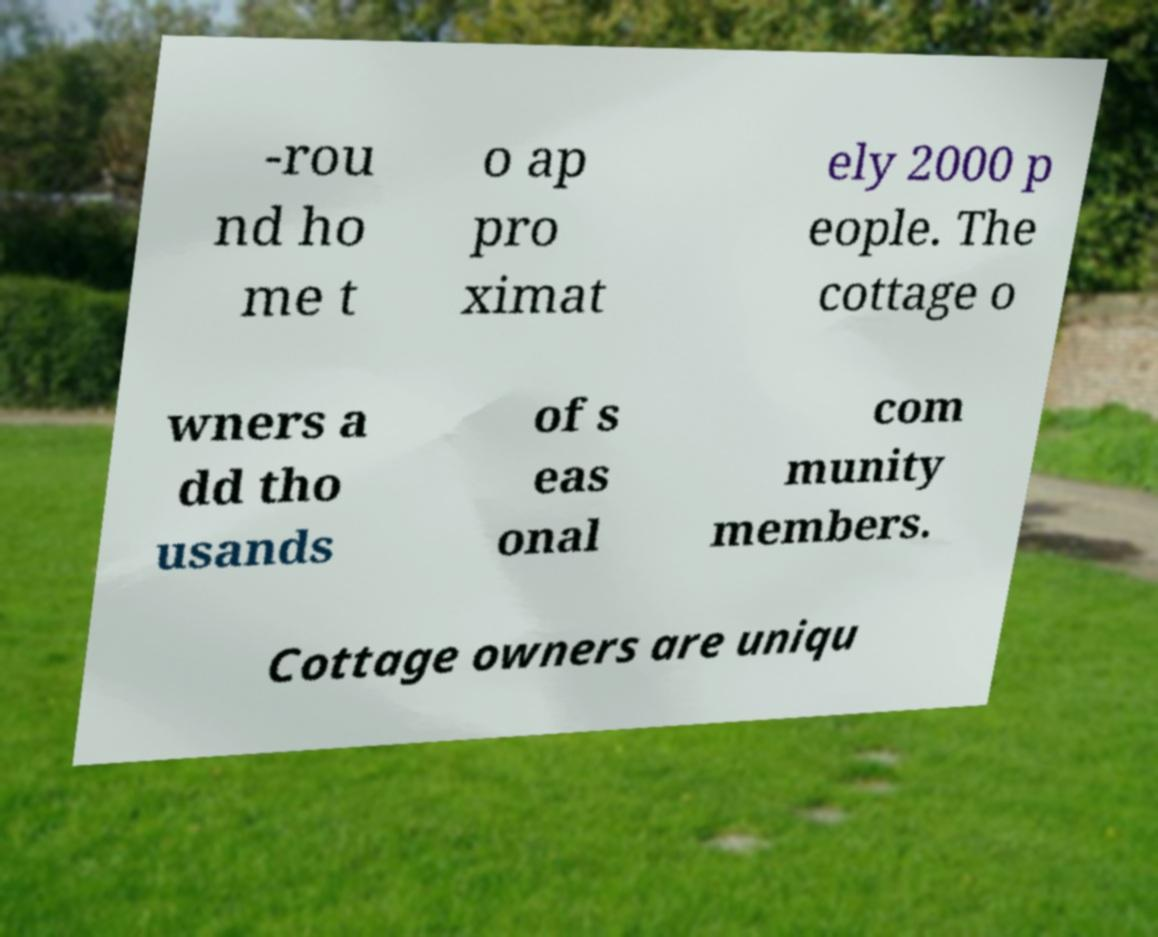Could you extract and type out the text from this image? -rou nd ho me t o ap pro ximat ely 2000 p eople. The cottage o wners a dd tho usands of s eas onal com munity members. Cottage owners are uniqu 